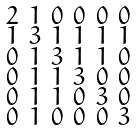<formula> <loc_0><loc_0><loc_500><loc_500>\begin{smallmatrix} 2 & 1 & 0 & 0 & 0 & 0 \\ 1 & 3 & 1 & 1 & 1 & 1 \\ 0 & 1 & 3 & 1 & 1 & 0 \\ 0 & 1 & 1 & 3 & 0 & 0 \\ 0 & 1 & 1 & 0 & 3 & 0 \\ 0 & 1 & 0 & 0 & 0 & 3 \end{smallmatrix}</formula> 